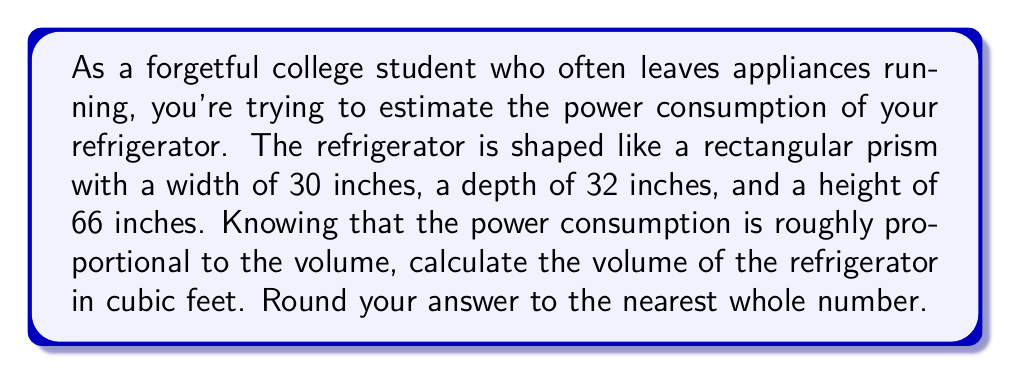Can you solve this math problem? To solve this problem, we need to follow these steps:

1. Convert all measurements to feet:
   - Width: $30 \text{ inches} \times \frac{1 \text{ foot}}{12 \text{ inches}} = 2.5 \text{ feet}$
   - Depth: $32 \text{ inches} \times \frac{1 \text{ foot}}{12 \text{ inches}} = \frac{8}{3} \text{ feet}$
   - Height: $66 \text{ inches} \times \frac{1 \text{ foot}}{12 \text{ inches}} = 5.5 \text{ feet}$

2. Calculate the volume using the formula for a rectangular prism:
   $$V = l \times w \times h$$
   Where $V$ is volume, $l$ is length (depth in this case), $w$ is width, and $h$ is height.

3. Substitute the values:
   $$V = \frac{8}{3} \times 2.5 \times 5.5$$

4. Multiply the fractions:
   $$V = \frac{8}{3} \times \frac{5}{2} \times \frac{11}{2}$$
   $$V = \frac{440}{12} = \frac{110}{3} \approx 36.67 \text{ cubic feet}$$

5. Round to the nearest whole number:
   36.67 rounds to 37 cubic feet.
Answer: 37 cubic feet 